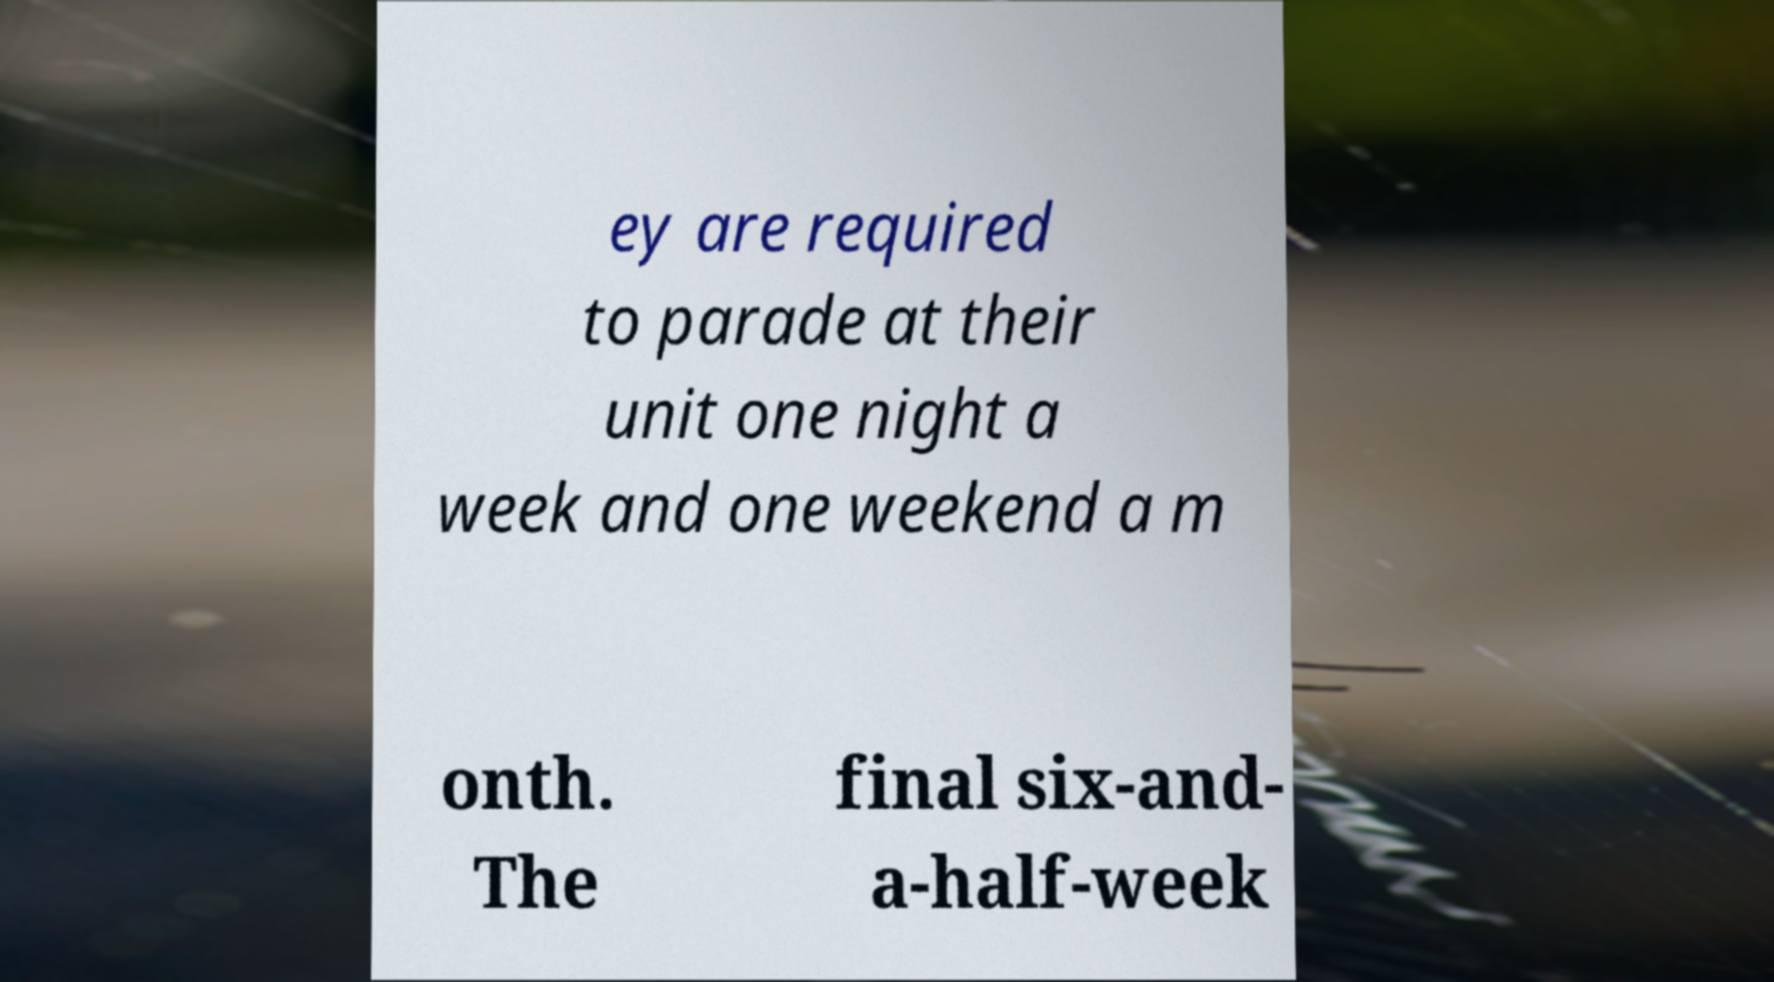What messages or text are displayed in this image? I need them in a readable, typed format. ey are required to parade at their unit one night a week and one weekend a m onth. The final six-and- a-half-week 